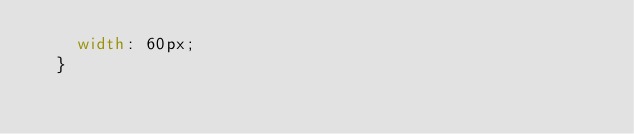<code> <loc_0><loc_0><loc_500><loc_500><_CSS_>    width: 60px;
  }</code> 